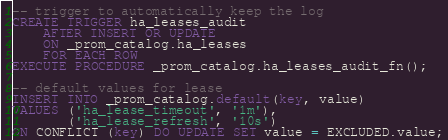<code> <loc_0><loc_0><loc_500><loc_500><_SQL_>-- trigger to automatically keep the log
CREATE TRIGGER ha_leases_audit
    AFTER INSERT OR UPDATE
    ON _prom_catalog.ha_leases
    FOR EACH ROW
EXECUTE PROCEDURE _prom_catalog.ha_leases_audit_fn();

-- default values for lease
INSERT INTO _prom_catalog.default(key, value)
VALUES ('ha_lease_timeout', '1m'),
       ('ha_lease_refresh', '10s')
ON CONFLICT (key) DO UPDATE SET value = EXCLUDED.value;
</code> 